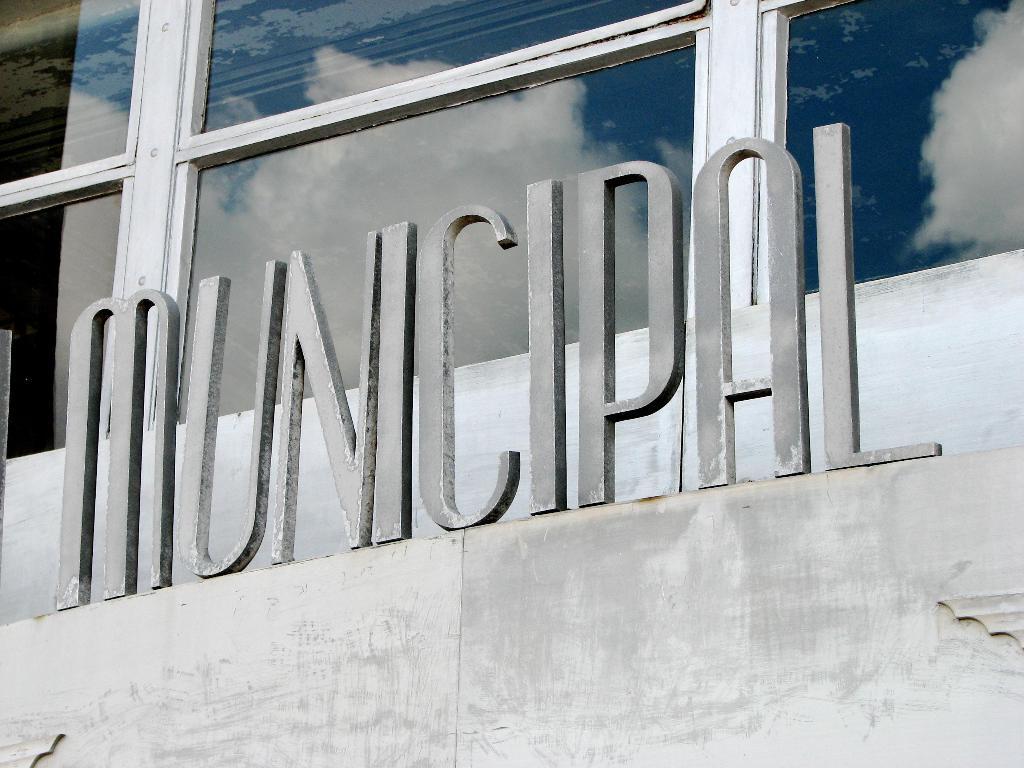Could you give a brief overview of what you see in this image? There is municipal placed on an object and there is a glass window behind it. 